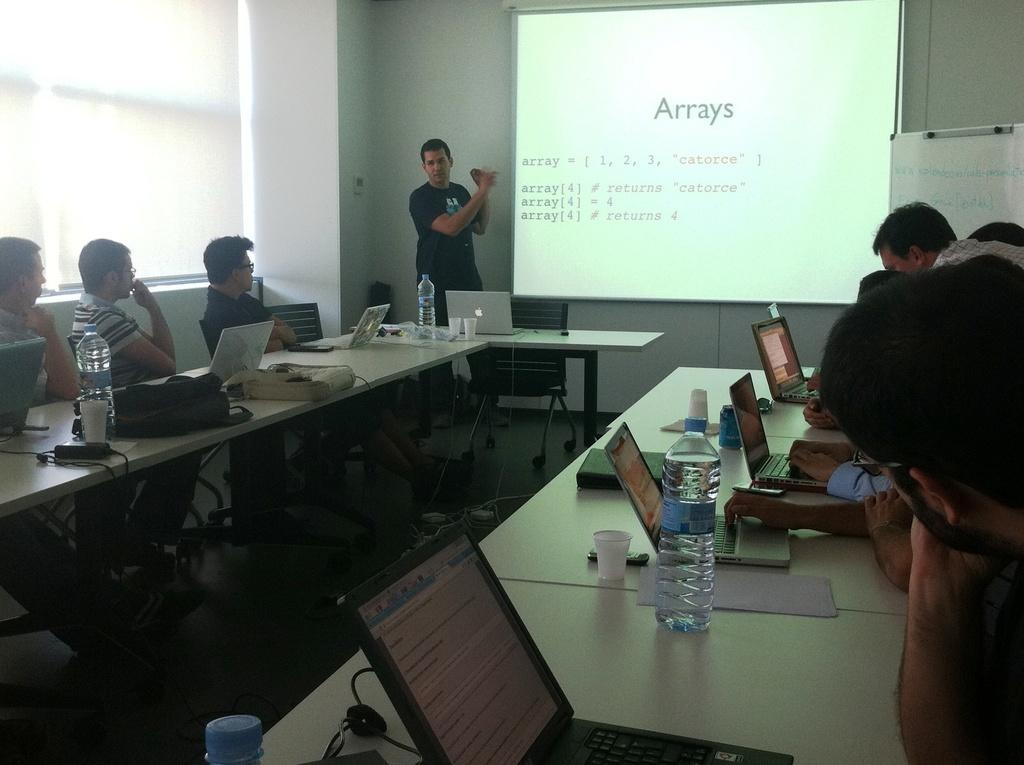<image>
Relay a brief, clear account of the picture shown. A classroom filled with people with projector showing a slide about Arrays. 